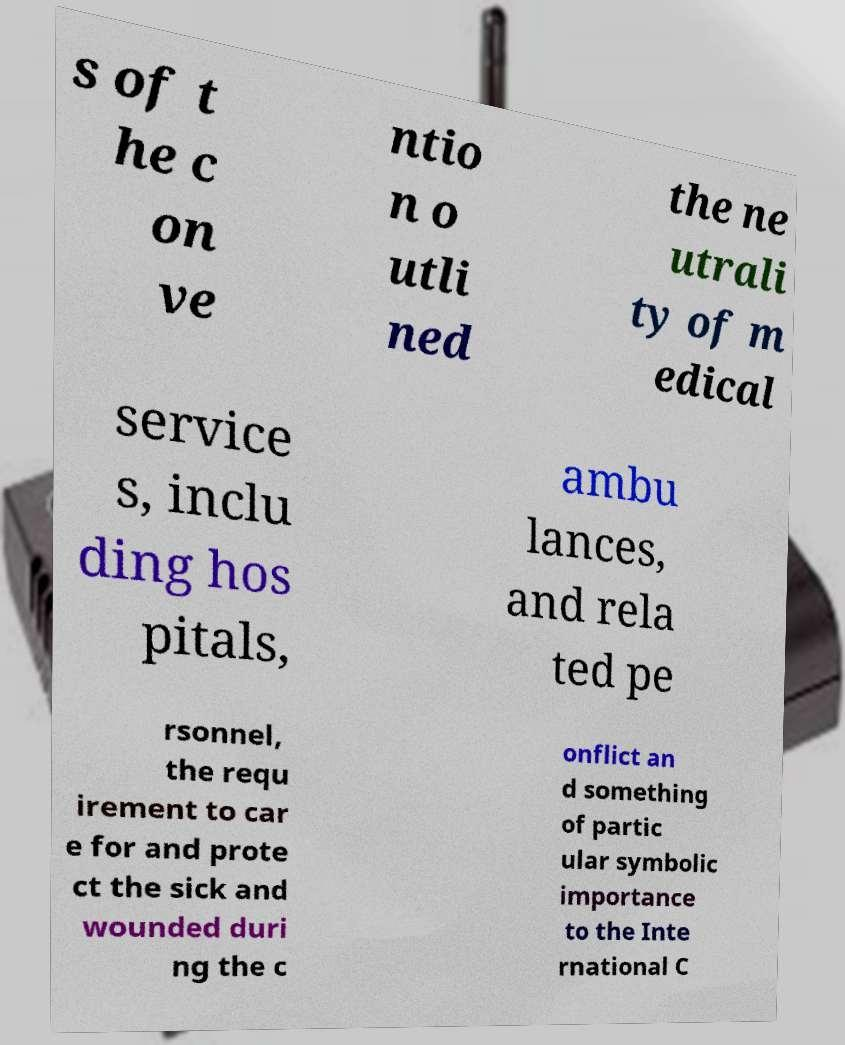For documentation purposes, I need the text within this image transcribed. Could you provide that? s of t he c on ve ntio n o utli ned the ne utrali ty of m edical service s, inclu ding hos pitals, ambu lances, and rela ted pe rsonnel, the requ irement to car e for and prote ct the sick and wounded duri ng the c onflict an d something of partic ular symbolic importance to the Inte rnational C 